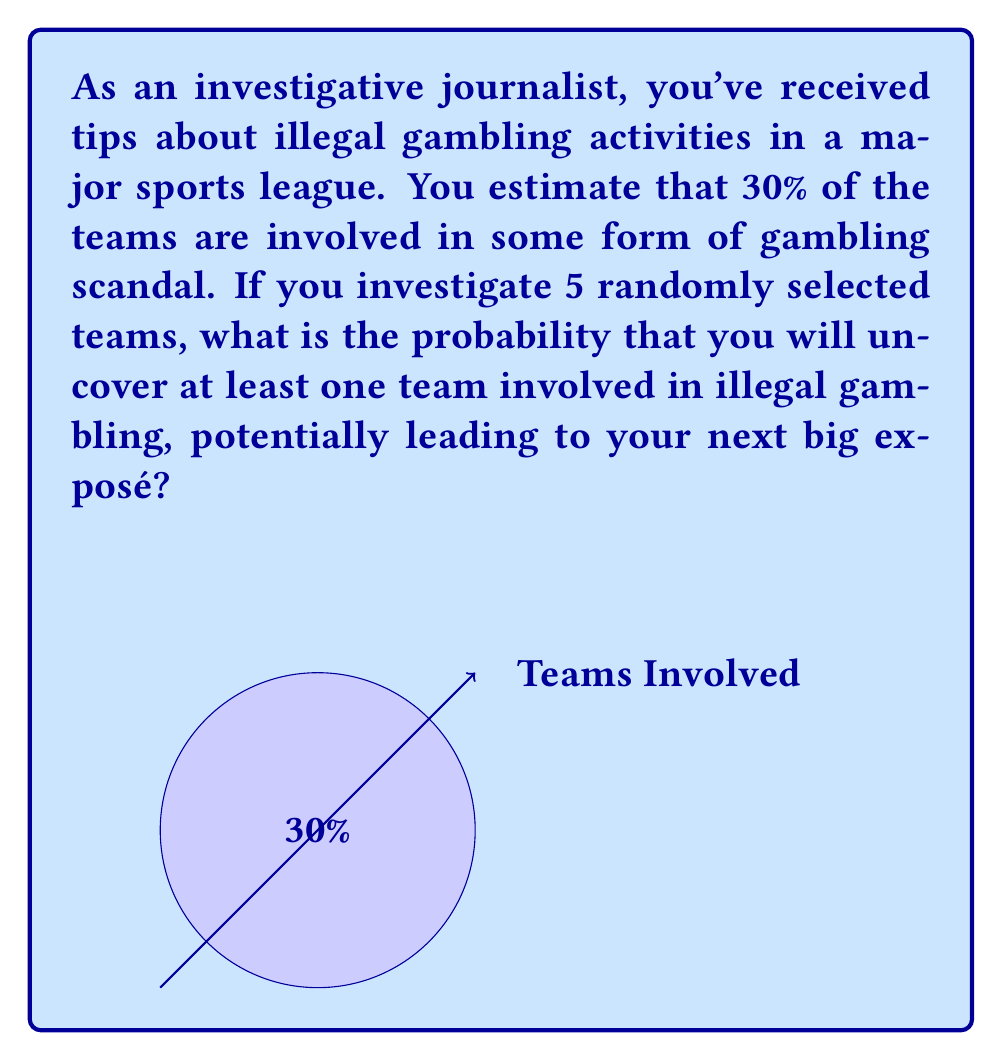Could you help me with this problem? Let's approach this step-by-step:

1) First, we need to consider the probability of a team not being involved in illegal gambling. If 30% are involved, then 70% are not involved.

2) The probability of not uncovering a scandal when investigating one team is 0.7 or 70%.

3) We're investigating 5 teams independently. To find the probability of not uncovering a scandal in any of these 5 investigations, we multiply the individual probabilities:

   $$(0.7)^5 = 0.16807$$

4) This 0.16807 represents the probability of not uncovering any scandal in 5 investigations.

5) Therefore, the probability of uncovering at least one scandal (which is what we're looking for) is the complement of this probability:

   $$1 - (0.7)^5 = 1 - 0.16807 = 0.83193$$

6) To convert to a percentage, we multiply by 100:

   $$0.83193 \times 100 = 83.193\%$$

Thus, there's approximately an 83.2% chance of uncovering at least one team involved in illegal gambling when investigating 5 random teams.
Answer: $$83.2\%$$ 